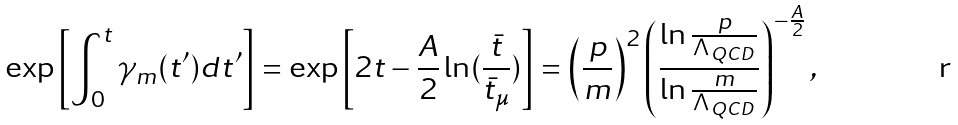Convert formula to latex. <formula><loc_0><loc_0><loc_500><loc_500>\exp \left [ \int _ { 0 } ^ { t } \gamma _ { m } ( t ^ { \prime } ) d t ^ { \prime } \right ] = \exp \left [ 2 t - \frac { A } { 2 } \ln ( \frac { \bar { t } } { { \bar { t } } _ { \mu } } ) \right ] = \left ( \frac { p } { m } \right ) ^ { 2 } \left ( \frac { \ln \frac { p } { \Lambda _ { Q C D } } } { \ln \frac { m } { \Lambda _ { Q C D } } } \right ) ^ { - \frac { A } { 2 } } ,</formula> 